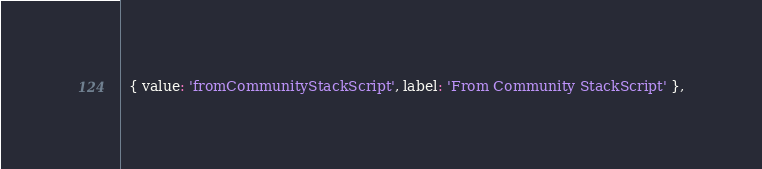<code> <loc_0><loc_0><loc_500><loc_500><_TypeScript_>  { value: 'fromCommunityStackScript', label: 'From Community StackScript' },</code> 